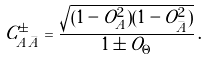<formula> <loc_0><loc_0><loc_500><loc_500>C ^ { \pm } _ { A \bar { A } } = \frac { \sqrt { ( 1 - O _ { A } ^ { 2 } ) ( 1 - O _ { \bar { A } } ^ { 2 } ) } } { 1 \pm O _ { \Theta } } \, .</formula> 